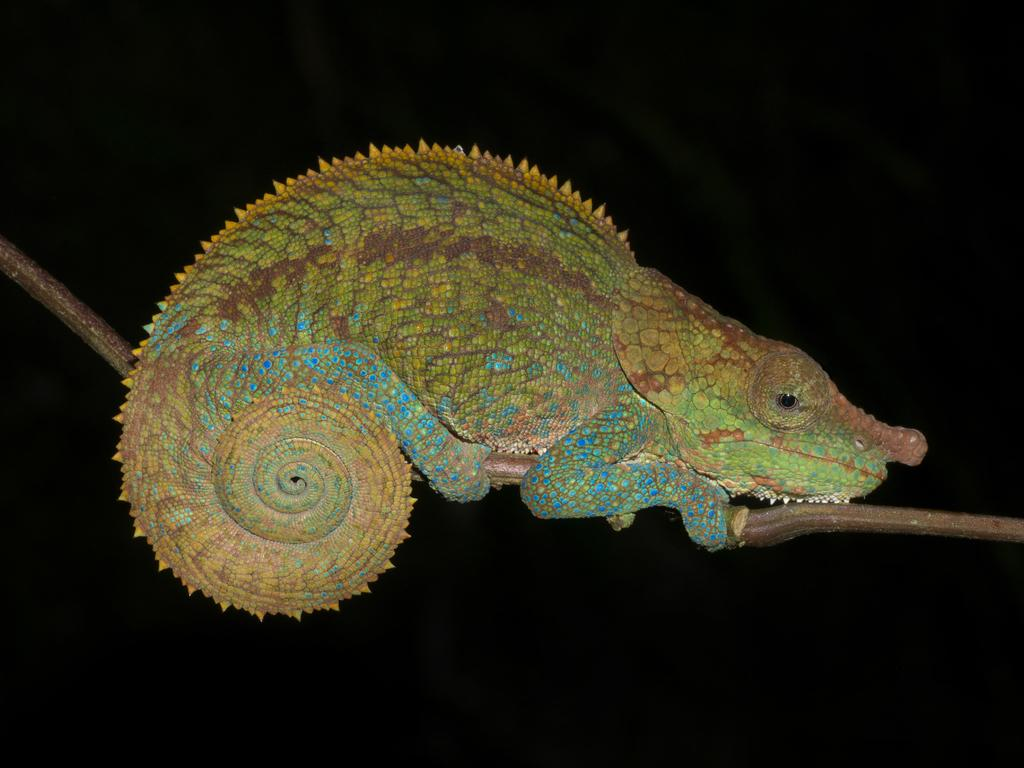What type of animal is in the image? There is a reptile in the image. What can be observed about the background of the image? The background of the image is dark. How does the reptile get a haircut in the image? There is no indication in the image that the reptile is getting a haircut, nor is there any evidence of hair on the reptile. 